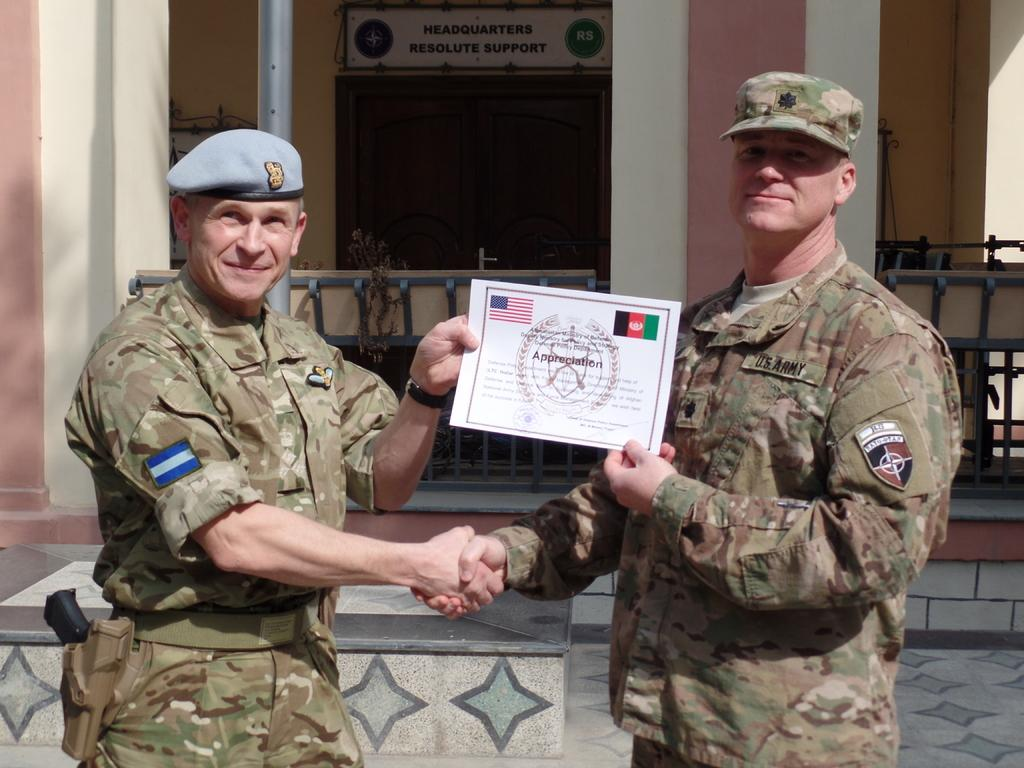How many people are in the image? There are two persons in the image. What are the persons holding in the image? The persons are holding a certificate. What can be seen in the background of the image? There is a building, a railing, and a pole visible in the background. Is there any text present in the image? Yes, there is text on the wall. What type of jeans are the persons wearing in the image? There is no information about the persons' clothing in the image, so we cannot determine if they are wearing jeans or any other type of clothing. What is the rate of the cars passing by in the image? There are no cars present in the image, so we cannot determine the rate at which they might be passing by. 